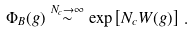Convert formula to latex. <formula><loc_0><loc_0><loc_500><loc_500>\Phi _ { B } ( g ) \overset { N _ { c } \rightarrow \infty } { \sim } \exp \left [ N _ { c } W ( g ) \right ] \, .</formula> 